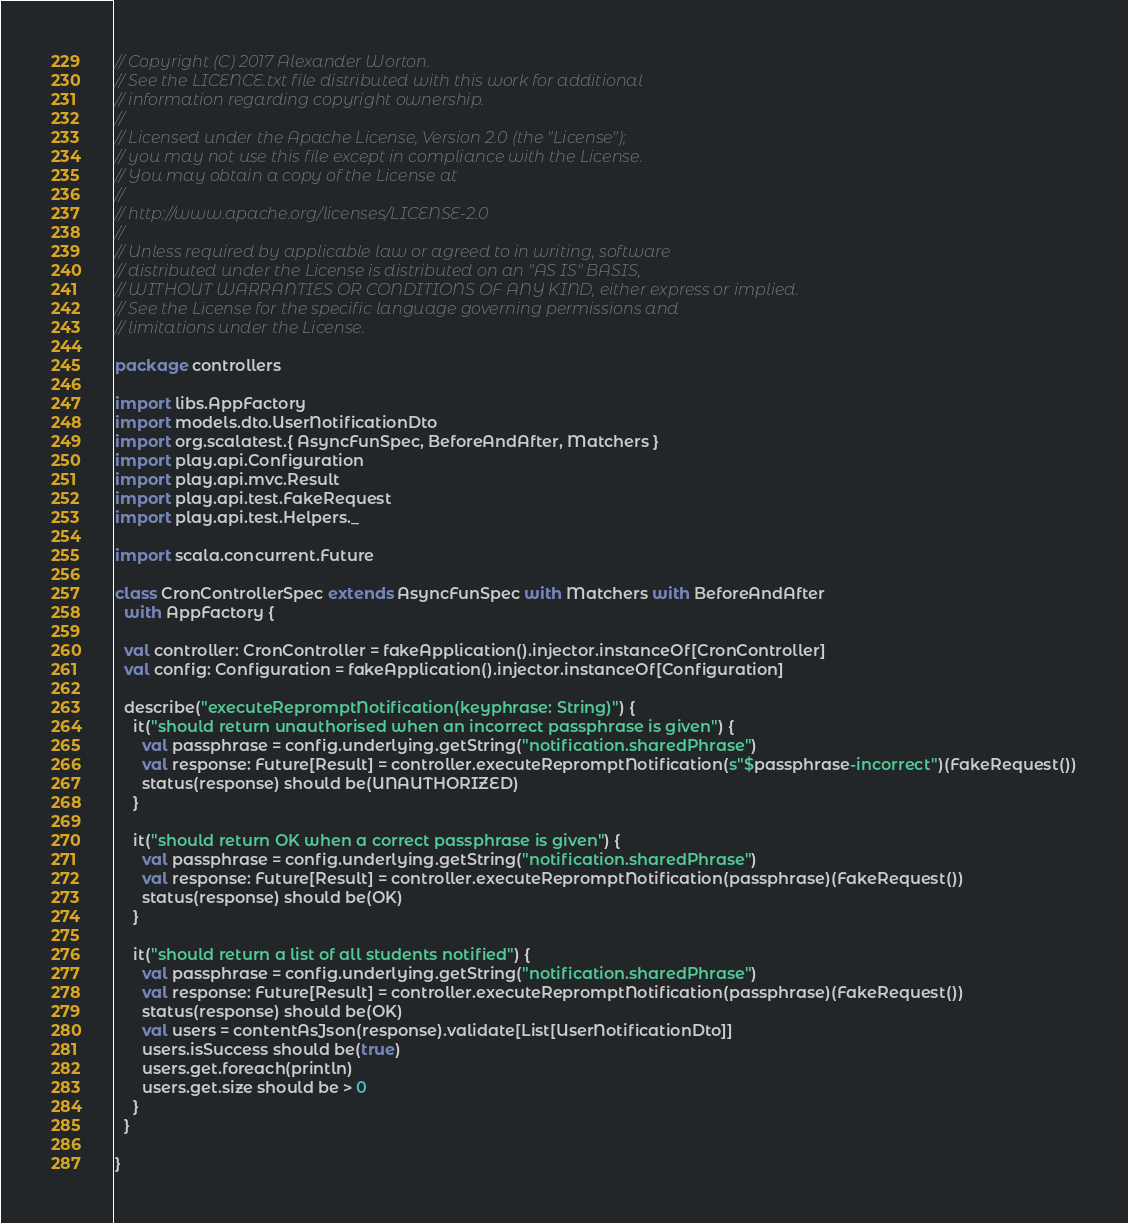<code> <loc_0><loc_0><loc_500><loc_500><_Scala_>// Copyright (C) 2017 Alexander Worton.
// See the LICENCE.txt file distributed with this work for additional
// information regarding copyright ownership.
//
// Licensed under the Apache License, Version 2.0 (the "License");
// you may not use this file except in compliance with the License.
// You may obtain a copy of the License at
//
// http://www.apache.org/licenses/LICENSE-2.0
//
// Unless required by applicable law or agreed to in writing, software
// distributed under the License is distributed on an "AS IS" BASIS,
// WITHOUT WARRANTIES OR CONDITIONS OF ANY KIND, either express or implied.
// See the License for the specific language governing permissions and
// limitations under the License.

package controllers

import libs.AppFactory
import models.dto.UserNotificationDto
import org.scalatest.{ AsyncFunSpec, BeforeAndAfter, Matchers }
import play.api.Configuration
import play.api.mvc.Result
import play.api.test.FakeRequest
import play.api.test.Helpers._

import scala.concurrent.Future

class CronControllerSpec extends AsyncFunSpec with Matchers with BeforeAndAfter
  with AppFactory {

  val controller: CronController = fakeApplication().injector.instanceOf[CronController]
  val config: Configuration = fakeApplication().injector.instanceOf[Configuration]

  describe("executeRepromptNotification(keyphrase: String)") {
    it("should return unauthorised when an incorrect passphrase is given") {
      val passphrase = config.underlying.getString("notification.sharedPhrase")
      val response: Future[Result] = controller.executeRepromptNotification(s"$passphrase-incorrect")(FakeRequest())
      status(response) should be(UNAUTHORIZED)
    }

    it("should return OK when a correct passphrase is given") {
      val passphrase = config.underlying.getString("notification.sharedPhrase")
      val response: Future[Result] = controller.executeRepromptNotification(passphrase)(FakeRequest())
      status(response) should be(OK)
    }

    it("should return a list of all students notified") {
      val passphrase = config.underlying.getString("notification.sharedPhrase")
      val response: Future[Result] = controller.executeRepromptNotification(passphrase)(FakeRequest())
      status(response) should be(OK)
      val users = contentAsJson(response).validate[List[UserNotificationDto]]
      users.isSuccess should be(true)
      users.get.foreach(println)
      users.get.size should be > 0
    }
  }

}
</code> 